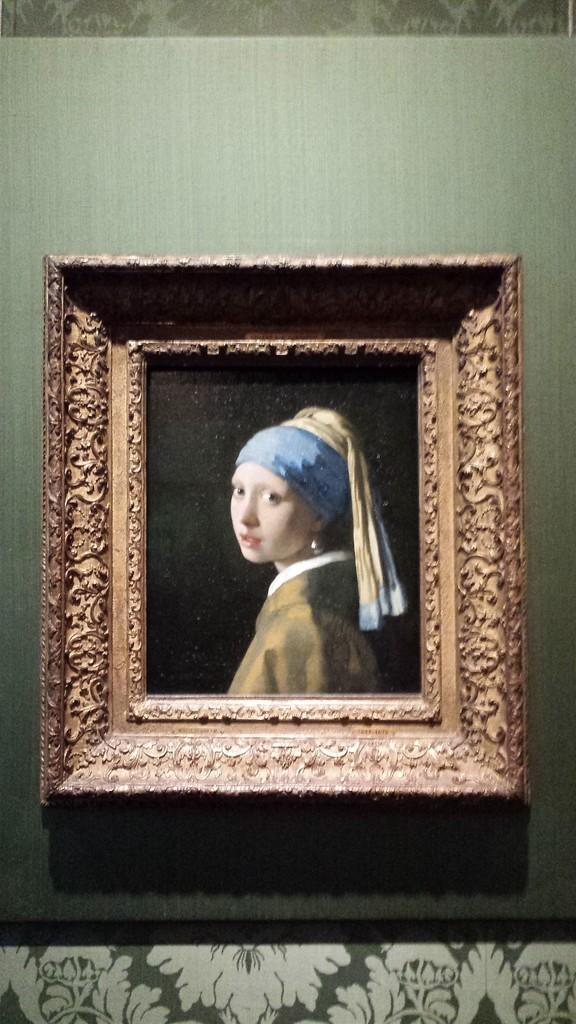What is hanging on the wall in the image? There is a frame of a woman on the wall in the image. How many cherries are on the goose in the image? There is no goose or cherries present in the image; it only features a frame of a woman on the wall. 